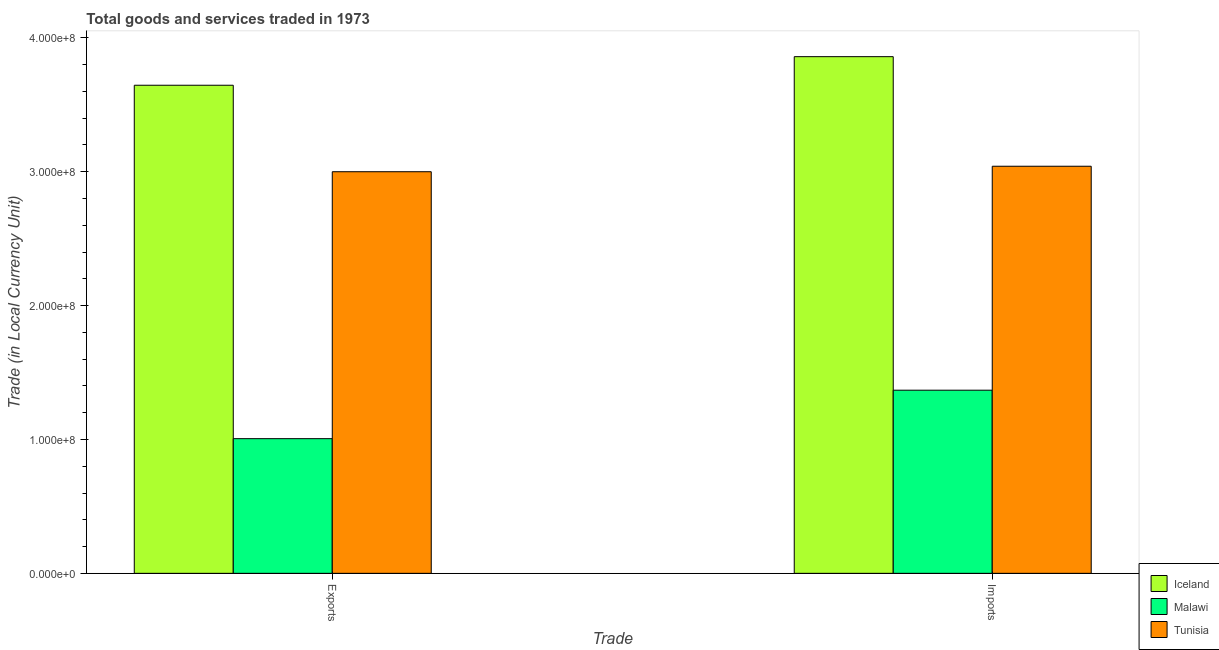Are the number of bars on each tick of the X-axis equal?
Your answer should be very brief. Yes. How many bars are there on the 1st tick from the right?
Your answer should be compact. 3. What is the label of the 1st group of bars from the left?
Offer a very short reply. Exports. What is the export of goods and services in Tunisia?
Provide a short and direct response. 3.00e+08. Across all countries, what is the maximum export of goods and services?
Offer a very short reply. 3.65e+08. Across all countries, what is the minimum imports of goods and services?
Keep it short and to the point. 1.37e+08. In which country was the export of goods and services maximum?
Make the answer very short. Iceland. In which country was the imports of goods and services minimum?
Keep it short and to the point. Malawi. What is the total export of goods and services in the graph?
Your answer should be very brief. 7.65e+08. What is the difference between the export of goods and services in Tunisia and that in Iceland?
Ensure brevity in your answer.  -6.46e+07. What is the difference between the export of goods and services in Malawi and the imports of goods and services in Tunisia?
Your answer should be very brief. -2.04e+08. What is the average export of goods and services per country?
Provide a succinct answer. 2.55e+08. What is the difference between the export of goods and services and imports of goods and services in Malawi?
Keep it short and to the point. -3.62e+07. In how many countries, is the imports of goods and services greater than 20000000 LCU?
Your answer should be very brief. 3. What is the ratio of the export of goods and services in Iceland to that in Malawi?
Offer a terse response. 3.62. In how many countries, is the imports of goods and services greater than the average imports of goods and services taken over all countries?
Ensure brevity in your answer.  2. What does the 1st bar from the right in Exports represents?
Your answer should be very brief. Tunisia. Are the values on the major ticks of Y-axis written in scientific E-notation?
Ensure brevity in your answer.  Yes. Does the graph contain grids?
Your answer should be compact. No. What is the title of the graph?
Give a very brief answer. Total goods and services traded in 1973. Does "Japan" appear as one of the legend labels in the graph?
Offer a very short reply. No. What is the label or title of the X-axis?
Ensure brevity in your answer.  Trade. What is the label or title of the Y-axis?
Your answer should be very brief. Trade (in Local Currency Unit). What is the Trade (in Local Currency Unit) in Iceland in Exports?
Make the answer very short. 3.65e+08. What is the Trade (in Local Currency Unit) of Malawi in Exports?
Your answer should be compact. 1.01e+08. What is the Trade (in Local Currency Unit) in Tunisia in Exports?
Provide a succinct answer. 3.00e+08. What is the Trade (in Local Currency Unit) of Iceland in Imports?
Ensure brevity in your answer.  3.86e+08. What is the Trade (in Local Currency Unit) of Malawi in Imports?
Your answer should be compact. 1.37e+08. What is the Trade (in Local Currency Unit) of Tunisia in Imports?
Provide a short and direct response. 3.04e+08. Across all Trade, what is the maximum Trade (in Local Currency Unit) in Iceland?
Offer a very short reply. 3.86e+08. Across all Trade, what is the maximum Trade (in Local Currency Unit) in Malawi?
Provide a succinct answer. 1.37e+08. Across all Trade, what is the maximum Trade (in Local Currency Unit) in Tunisia?
Ensure brevity in your answer.  3.04e+08. Across all Trade, what is the minimum Trade (in Local Currency Unit) of Iceland?
Make the answer very short. 3.65e+08. Across all Trade, what is the minimum Trade (in Local Currency Unit) of Malawi?
Your answer should be very brief. 1.01e+08. Across all Trade, what is the minimum Trade (in Local Currency Unit) in Tunisia?
Offer a terse response. 3.00e+08. What is the total Trade (in Local Currency Unit) of Iceland in the graph?
Provide a succinct answer. 7.51e+08. What is the total Trade (in Local Currency Unit) of Malawi in the graph?
Make the answer very short. 2.37e+08. What is the total Trade (in Local Currency Unit) in Tunisia in the graph?
Your answer should be very brief. 6.04e+08. What is the difference between the Trade (in Local Currency Unit) of Iceland in Exports and that in Imports?
Ensure brevity in your answer.  -2.13e+07. What is the difference between the Trade (in Local Currency Unit) in Malawi in Exports and that in Imports?
Offer a very short reply. -3.62e+07. What is the difference between the Trade (in Local Currency Unit) in Tunisia in Exports and that in Imports?
Give a very brief answer. -4.10e+06. What is the difference between the Trade (in Local Currency Unit) in Iceland in Exports and the Trade (in Local Currency Unit) in Malawi in Imports?
Offer a terse response. 2.28e+08. What is the difference between the Trade (in Local Currency Unit) in Iceland in Exports and the Trade (in Local Currency Unit) in Tunisia in Imports?
Offer a terse response. 6.05e+07. What is the difference between the Trade (in Local Currency Unit) of Malawi in Exports and the Trade (in Local Currency Unit) of Tunisia in Imports?
Your response must be concise. -2.04e+08. What is the average Trade (in Local Currency Unit) in Iceland per Trade?
Offer a terse response. 3.75e+08. What is the average Trade (in Local Currency Unit) of Malawi per Trade?
Your response must be concise. 1.19e+08. What is the average Trade (in Local Currency Unit) in Tunisia per Trade?
Keep it short and to the point. 3.02e+08. What is the difference between the Trade (in Local Currency Unit) of Iceland and Trade (in Local Currency Unit) of Malawi in Exports?
Provide a succinct answer. 2.64e+08. What is the difference between the Trade (in Local Currency Unit) in Iceland and Trade (in Local Currency Unit) in Tunisia in Exports?
Make the answer very short. 6.46e+07. What is the difference between the Trade (in Local Currency Unit) in Malawi and Trade (in Local Currency Unit) in Tunisia in Exports?
Provide a short and direct response. -1.99e+08. What is the difference between the Trade (in Local Currency Unit) of Iceland and Trade (in Local Currency Unit) of Malawi in Imports?
Your response must be concise. 2.49e+08. What is the difference between the Trade (in Local Currency Unit) of Iceland and Trade (in Local Currency Unit) of Tunisia in Imports?
Keep it short and to the point. 8.19e+07. What is the difference between the Trade (in Local Currency Unit) of Malawi and Trade (in Local Currency Unit) of Tunisia in Imports?
Give a very brief answer. -1.67e+08. What is the ratio of the Trade (in Local Currency Unit) of Iceland in Exports to that in Imports?
Your answer should be compact. 0.94. What is the ratio of the Trade (in Local Currency Unit) of Malawi in Exports to that in Imports?
Your answer should be compact. 0.74. What is the ratio of the Trade (in Local Currency Unit) of Tunisia in Exports to that in Imports?
Offer a very short reply. 0.99. What is the difference between the highest and the second highest Trade (in Local Currency Unit) in Iceland?
Your answer should be very brief. 2.13e+07. What is the difference between the highest and the second highest Trade (in Local Currency Unit) of Malawi?
Offer a terse response. 3.62e+07. What is the difference between the highest and the second highest Trade (in Local Currency Unit) of Tunisia?
Keep it short and to the point. 4.10e+06. What is the difference between the highest and the lowest Trade (in Local Currency Unit) in Iceland?
Provide a short and direct response. 2.13e+07. What is the difference between the highest and the lowest Trade (in Local Currency Unit) of Malawi?
Offer a terse response. 3.62e+07. What is the difference between the highest and the lowest Trade (in Local Currency Unit) of Tunisia?
Ensure brevity in your answer.  4.10e+06. 